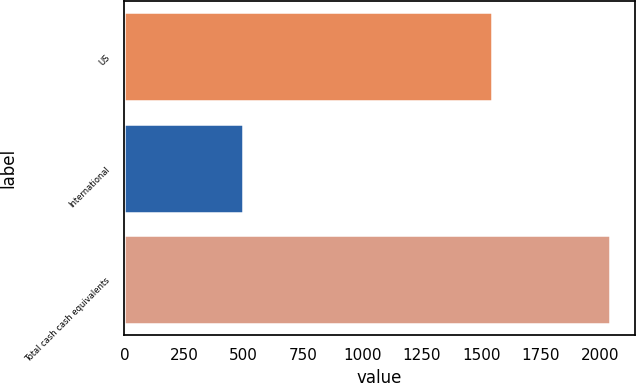Convert chart to OTSL. <chart><loc_0><loc_0><loc_500><loc_500><bar_chart><fcel>US<fcel>International<fcel>Total cash cash equivalents<nl><fcel>1544<fcel>499<fcel>2043<nl></chart> 